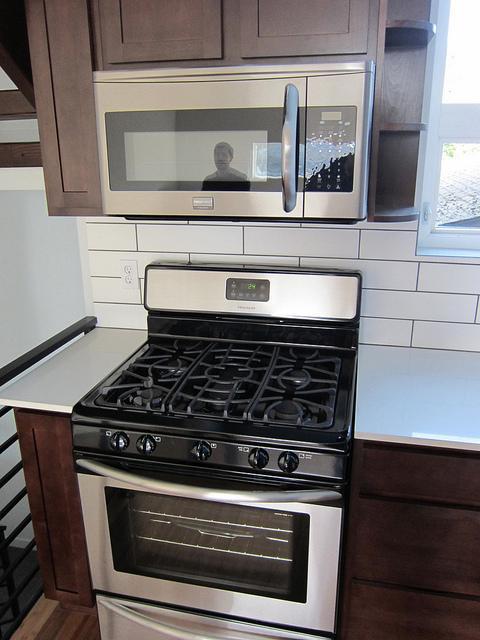Does the description: "The oven is at the left side of the person." accurately reflect the image?
Answer yes or no. No. 